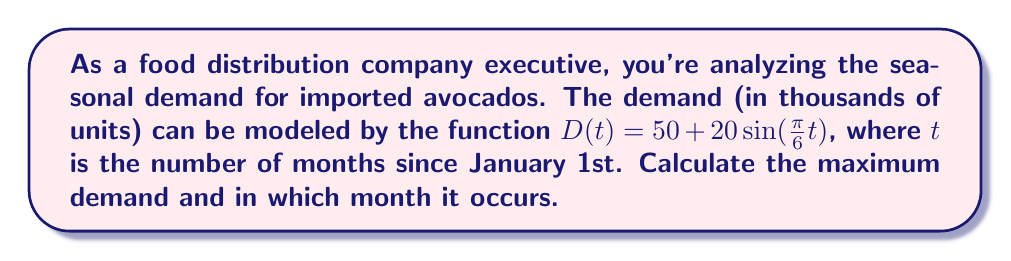Teach me how to tackle this problem. 1) The function $D(t) = 50 + 20\sin(\frac{\pi}{6}t)$ is a sinusoidal function where:
   - The midline is at 50
   - The amplitude is 20
   - The period is 12 months (because $\frac{2\pi}{\frac{\pi}{6}} = 12$)

2) The maximum value of a sine function occurs when $\sin(\theta) = 1$, which happens when $\theta = \frac{\pi}{2}$ (or 90°).

3) To find when this occurs, we solve:
   $$\frac{\pi}{6}t = \frac{\pi}{2}$$

4) Solving for $t$:
   $$t = \frac{\pi}{2} \cdot \frac{6}{\pi} = 3$$

5) This means the maximum occurs 3 months after January 1st, which is April.

6) To calculate the maximum demand:
   $$D_{max} = 50 + 20\sin(\frac{\pi}{2}) = 50 + 20 = 70$$

Therefore, the maximum demand is 70,000 units and occurs in April.
Answer: 70,000 units in April 